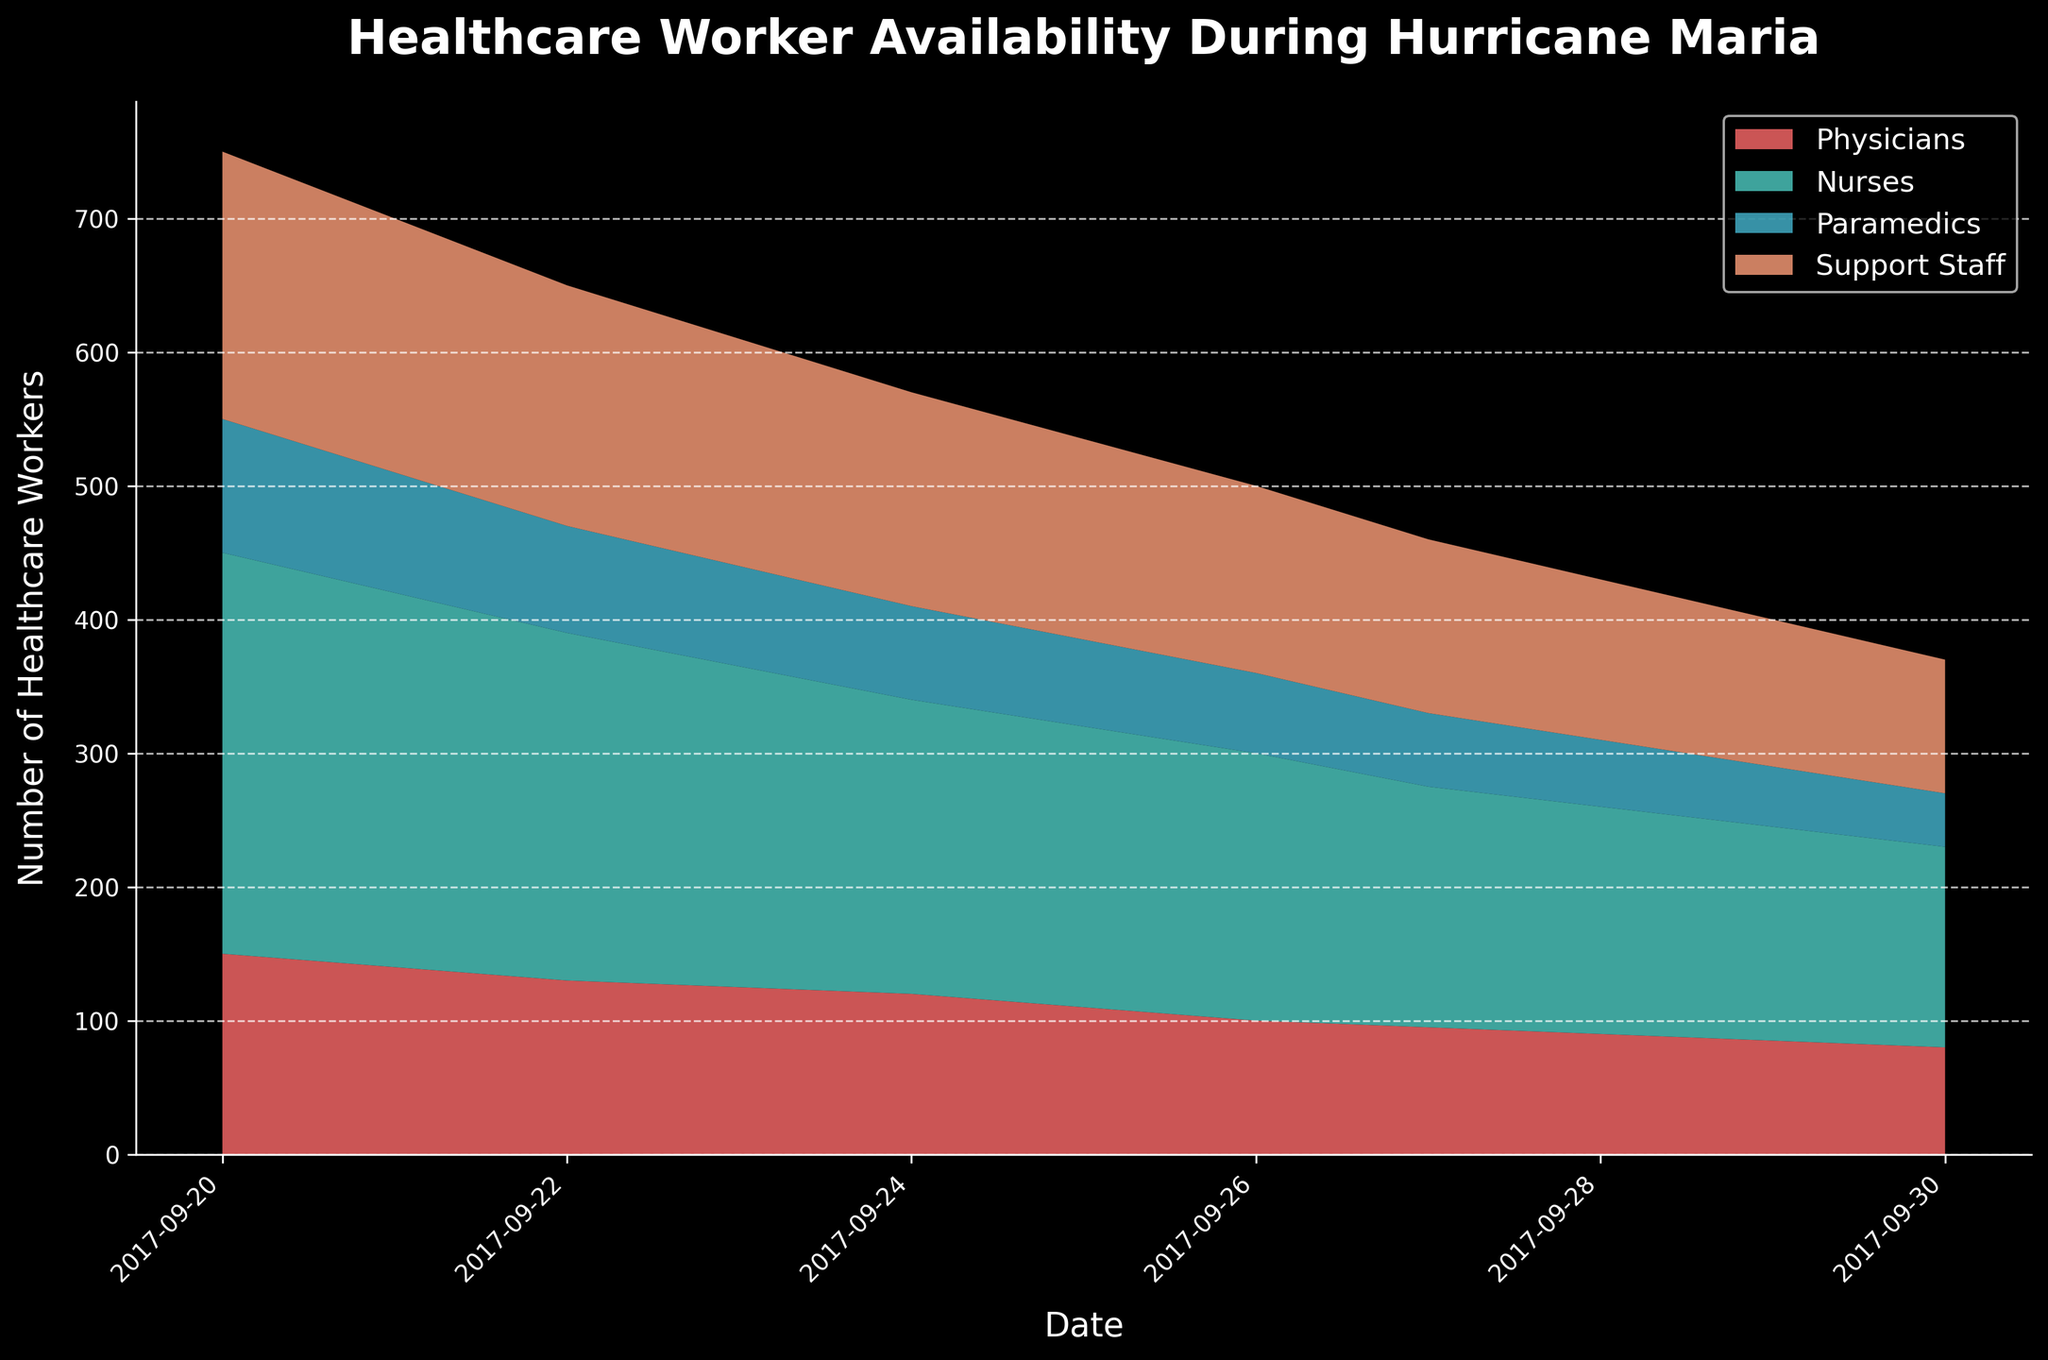What is the title of the chart? The chart's title is displayed at the top, which describes the content it represents.
Answer: Healthcare Worker Availability During Hurricane Maria On which date did Nurses' availability drop below 200? By examining the decreasing trend line for Nurses, we can see that it drops below 200 on September 26.
Answer: September 26 How many categories of healthcare workers are shown in the chart? The chart legend and area segments indicate the different categories of healthcare workers.
Answer: Four Which day saw the sharpest decline in Paramedic availability? By observing the slope of the Paramedic segment, the sharpest decline appears to be between September 20 and September 21.
Answer: September 21 What is the number of Support Staff available on September 29? You can trace the area corresponding to Support Staff down to the date on the x-axis at September 29.
Answer: 110 By how much did the number of Physicians drop from September 20 to September 30? The initial value on September 20 is 150, and the final value on September 30 is 80. The difference is calculated as 150 - 80.
Answer: 70 What is the combined availability of all healthcare workers on September 25? Sum up the values for Physicians, Nurses, Paramedics, and Support Staff on September 25: 110 + 210 + 65 + 150.
Answer: 535 Which category of healthcare workers experienced the least decline over the period shown? By comparing the initial and final values of each category, Support Staff shows the smallest decrease (200 to 100).
Answer: Support Staff Between September 24 and September 25, which healthcare category had the smallest decline in availability? Calculate the differences for each category during this period: Physicians (120-110=10), Nurses (220-210=10), Paramedics (70-65=5), Support Staff (160-150=10).
Answer: Paramedics On which dates are the number of healthcare workers synchronized for Nurses and Support Staff at roughly equal levels? Identify intervals where Nurses and Support Staff areas align visually, ensuring both are approximately equal: noticeable around September 29.
Answer: September 29 